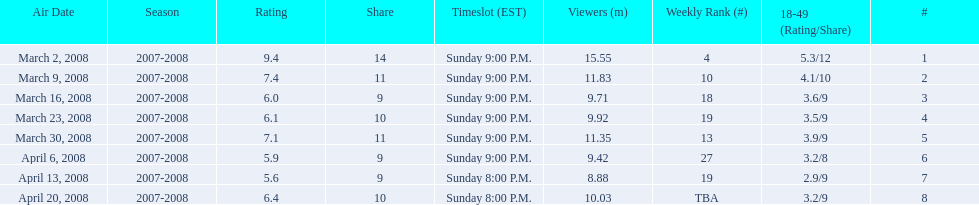How long did the program air for in days? 8. 